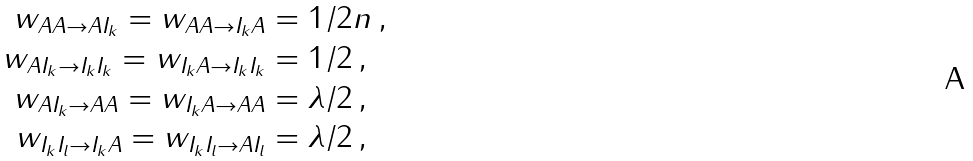Convert formula to latex. <formula><loc_0><loc_0><loc_500><loc_500>w _ { A A \rightarrow A I _ { k } } = w _ { A A \rightarrow I _ { k } A } & = 1 / 2 n \, , \\ w _ { A I _ { k } \rightarrow I _ { k } I _ { k } } = w _ { I _ { k } A \rightarrow I _ { k } I _ { k } } & = 1 / 2 \, , \\ w _ { A I _ { k } \rightarrow A A } = w _ { I _ { k } A \rightarrow A A } & = \lambda / 2 \, , \\ w _ { I _ { k } I _ { l } \rightarrow I _ { k } A } = w _ { I _ { k } I _ { l } \rightarrow A I _ { l } } & = \lambda / 2 \, ,</formula> 